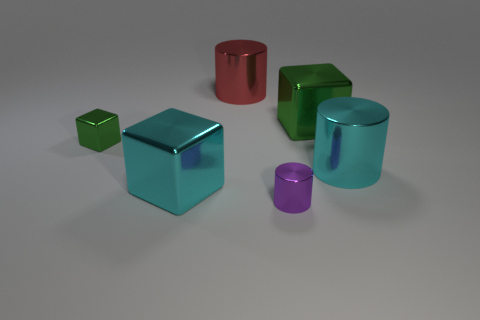Subtract all green metal cubes. How many cubes are left? 1 Subtract all blue cylinders. How many green cubes are left? 2 Subtract all blue cylinders. Subtract all yellow cubes. How many cylinders are left? 3 Add 1 large brown cubes. How many objects exist? 7 Subtract 0 gray blocks. How many objects are left? 6 Subtract all tiny blue things. Subtract all tiny metallic cylinders. How many objects are left? 5 Add 1 big cubes. How many big cubes are left? 3 Add 4 tiny purple metal cylinders. How many tiny purple metal cylinders exist? 5 